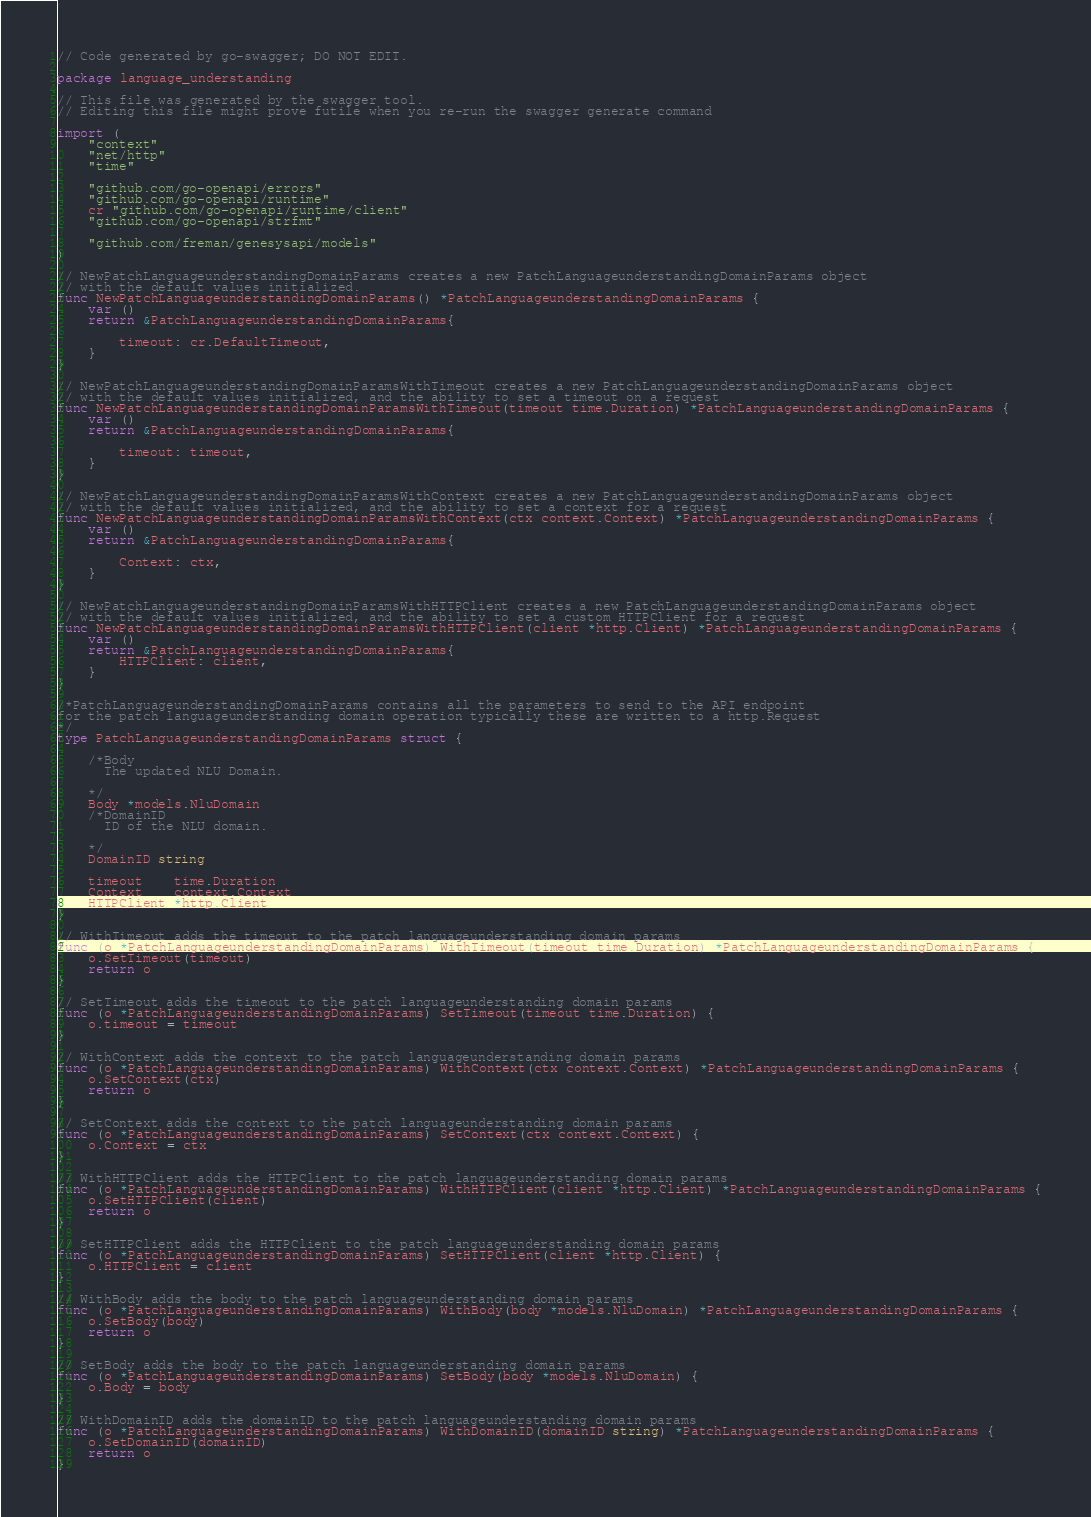<code> <loc_0><loc_0><loc_500><loc_500><_Go_>// Code generated by go-swagger; DO NOT EDIT.

package language_understanding

// This file was generated by the swagger tool.
// Editing this file might prove futile when you re-run the swagger generate command

import (
	"context"
	"net/http"
	"time"

	"github.com/go-openapi/errors"
	"github.com/go-openapi/runtime"
	cr "github.com/go-openapi/runtime/client"
	"github.com/go-openapi/strfmt"

	"github.com/freman/genesysapi/models"
)

// NewPatchLanguageunderstandingDomainParams creates a new PatchLanguageunderstandingDomainParams object
// with the default values initialized.
func NewPatchLanguageunderstandingDomainParams() *PatchLanguageunderstandingDomainParams {
	var ()
	return &PatchLanguageunderstandingDomainParams{

		timeout: cr.DefaultTimeout,
	}
}

// NewPatchLanguageunderstandingDomainParamsWithTimeout creates a new PatchLanguageunderstandingDomainParams object
// with the default values initialized, and the ability to set a timeout on a request
func NewPatchLanguageunderstandingDomainParamsWithTimeout(timeout time.Duration) *PatchLanguageunderstandingDomainParams {
	var ()
	return &PatchLanguageunderstandingDomainParams{

		timeout: timeout,
	}
}

// NewPatchLanguageunderstandingDomainParamsWithContext creates a new PatchLanguageunderstandingDomainParams object
// with the default values initialized, and the ability to set a context for a request
func NewPatchLanguageunderstandingDomainParamsWithContext(ctx context.Context) *PatchLanguageunderstandingDomainParams {
	var ()
	return &PatchLanguageunderstandingDomainParams{

		Context: ctx,
	}
}

// NewPatchLanguageunderstandingDomainParamsWithHTTPClient creates a new PatchLanguageunderstandingDomainParams object
// with the default values initialized, and the ability to set a custom HTTPClient for a request
func NewPatchLanguageunderstandingDomainParamsWithHTTPClient(client *http.Client) *PatchLanguageunderstandingDomainParams {
	var ()
	return &PatchLanguageunderstandingDomainParams{
		HTTPClient: client,
	}
}

/*PatchLanguageunderstandingDomainParams contains all the parameters to send to the API endpoint
for the patch languageunderstanding domain operation typically these are written to a http.Request
*/
type PatchLanguageunderstandingDomainParams struct {

	/*Body
	  The updated NLU Domain.

	*/
	Body *models.NluDomain
	/*DomainID
	  ID of the NLU domain.

	*/
	DomainID string

	timeout    time.Duration
	Context    context.Context
	HTTPClient *http.Client
}

// WithTimeout adds the timeout to the patch languageunderstanding domain params
func (o *PatchLanguageunderstandingDomainParams) WithTimeout(timeout time.Duration) *PatchLanguageunderstandingDomainParams {
	o.SetTimeout(timeout)
	return o
}

// SetTimeout adds the timeout to the patch languageunderstanding domain params
func (o *PatchLanguageunderstandingDomainParams) SetTimeout(timeout time.Duration) {
	o.timeout = timeout
}

// WithContext adds the context to the patch languageunderstanding domain params
func (o *PatchLanguageunderstandingDomainParams) WithContext(ctx context.Context) *PatchLanguageunderstandingDomainParams {
	o.SetContext(ctx)
	return o
}

// SetContext adds the context to the patch languageunderstanding domain params
func (o *PatchLanguageunderstandingDomainParams) SetContext(ctx context.Context) {
	o.Context = ctx
}

// WithHTTPClient adds the HTTPClient to the patch languageunderstanding domain params
func (o *PatchLanguageunderstandingDomainParams) WithHTTPClient(client *http.Client) *PatchLanguageunderstandingDomainParams {
	o.SetHTTPClient(client)
	return o
}

// SetHTTPClient adds the HTTPClient to the patch languageunderstanding domain params
func (o *PatchLanguageunderstandingDomainParams) SetHTTPClient(client *http.Client) {
	o.HTTPClient = client
}

// WithBody adds the body to the patch languageunderstanding domain params
func (o *PatchLanguageunderstandingDomainParams) WithBody(body *models.NluDomain) *PatchLanguageunderstandingDomainParams {
	o.SetBody(body)
	return o
}

// SetBody adds the body to the patch languageunderstanding domain params
func (o *PatchLanguageunderstandingDomainParams) SetBody(body *models.NluDomain) {
	o.Body = body
}

// WithDomainID adds the domainID to the patch languageunderstanding domain params
func (o *PatchLanguageunderstandingDomainParams) WithDomainID(domainID string) *PatchLanguageunderstandingDomainParams {
	o.SetDomainID(domainID)
	return o
}
</code> 